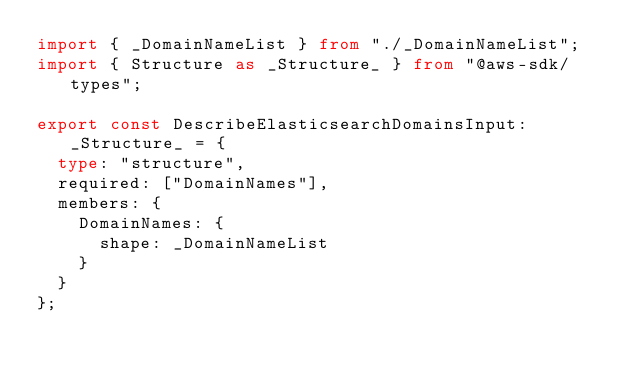<code> <loc_0><loc_0><loc_500><loc_500><_TypeScript_>import { _DomainNameList } from "./_DomainNameList";
import { Structure as _Structure_ } from "@aws-sdk/types";

export const DescribeElasticsearchDomainsInput: _Structure_ = {
  type: "structure",
  required: ["DomainNames"],
  members: {
    DomainNames: {
      shape: _DomainNameList
    }
  }
};
</code> 